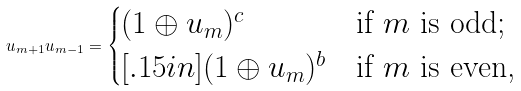Convert formula to latex. <formula><loc_0><loc_0><loc_500><loc_500>u _ { m + 1 } u _ { m - 1 } = \begin{cases} ( 1 \oplus u _ { m } ) ^ { c } & \text {if $m$ is odd;} \\ [ . 1 5 i n ] ( 1 \oplus u _ { m } ) ^ { b } & \text {if $m$ is even,} \end{cases}</formula> 